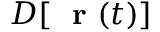Convert formula to latex. <formula><loc_0><loc_0><loc_500><loc_500>D [ r ( t ) ]</formula> 